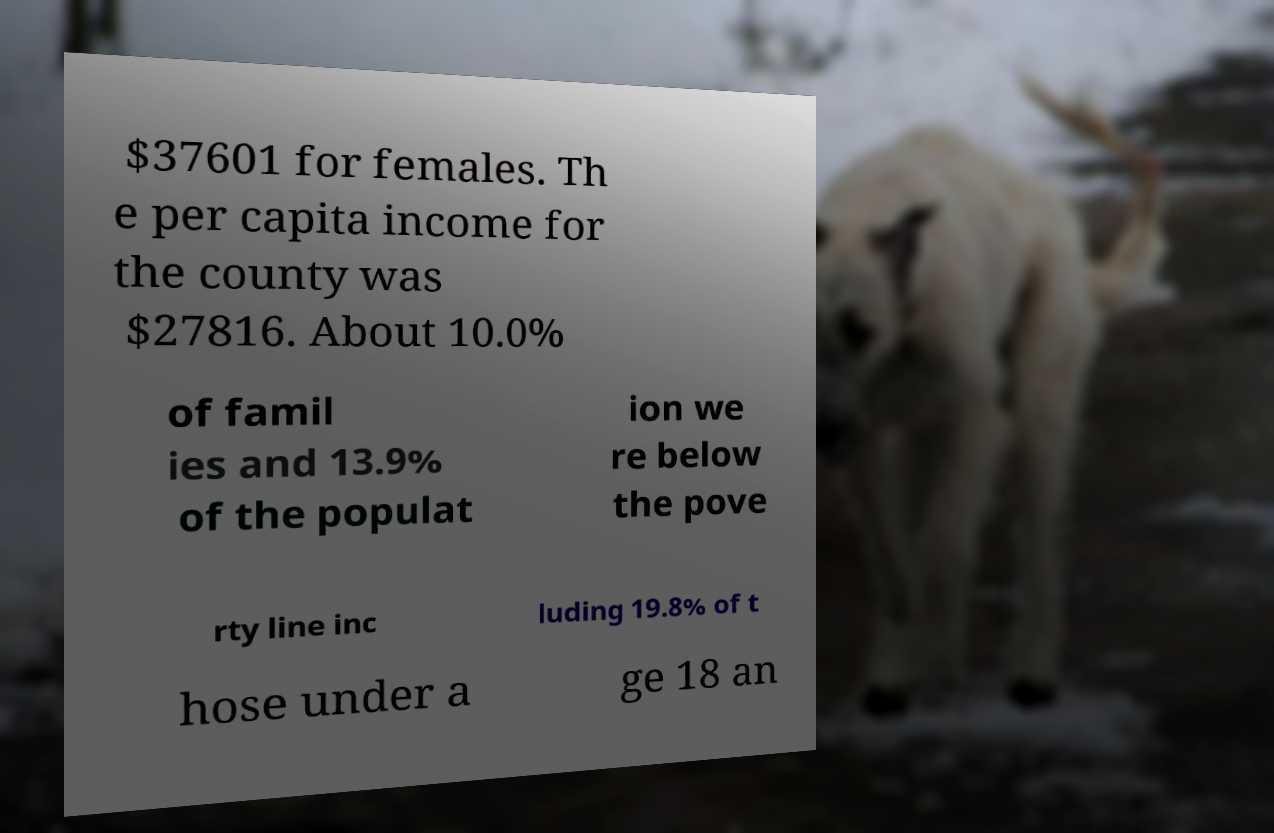Please read and relay the text visible in this image. What does it say? $37601 for females. Th e per capita income for the county was $27816. About 10.0% of famil ies and 13.9% of the populat ion we re below the pove rty line inc luding 19.8% of t hose under a ge 18 an 